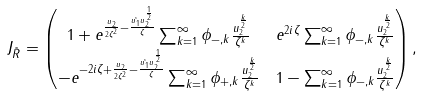Convert formula to latex. <formula><loc_0><loc_0><loc_500><loc_500>J _ { \tilde { R } } & = \begin{pmatrix} 1 + e ^ { \frac { u _ { 2 } } { 2 \zeta ^ { 2 } } - \frac { \tilde { u _ { 1 } } u _ { 2 } ^ { \frac { 1 } { 2 } } } { \zeta } } \sum _ { k = 1 } ^ { \infty } \phi _ { - , k } \frac { u _ { 2 } ^ { \frac { k } { 2 } } } { \zeta ^ { k } } & e ^ { 2 i \zeta } \sum _ { k = 1 } ^ { \infty } \phi _ { - , k } \frac { u _ { 2 } ^ { \frac { k } { 2 } } } { \zeta ^ { k } } \\ - e ^ { - 2 i \zeta + \frac { u _ { 2 } } { 2 \zeta ^ { 2 } } - \frac { \tilde { u _ { 1 } } u _ { 2 } ^ { \frac { 1 } { 2 } } } { \zeta } } \sum _ { k = 1 } ^ { \infty } \phi _ { + , k } \frac { u _ { 2 } ^ { \frac { k } { 2 } } } { \zeta ^ { k } } & 1 - \sum _ { k = 1 } ^ { \infty } \phi _ { - , k } \frac { u _ { 2 } ^ { \frac { k } { 2 } } } { \zeta ^ { k } } \end{pmatrix} ,</formula> 